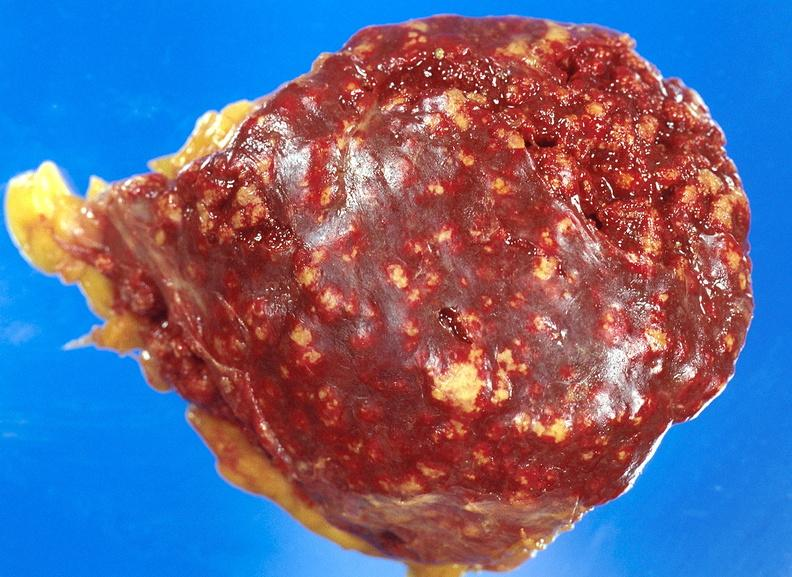where is this part in?
Answer the question using a single word or phrase. Spleen 